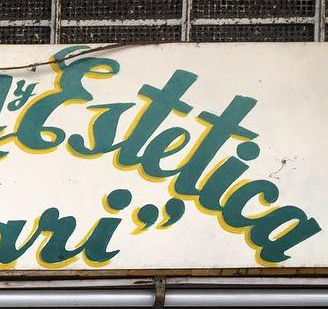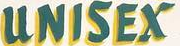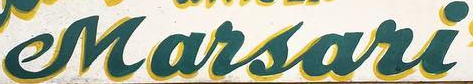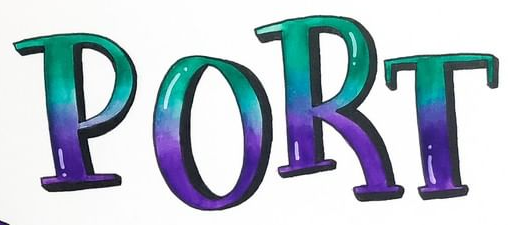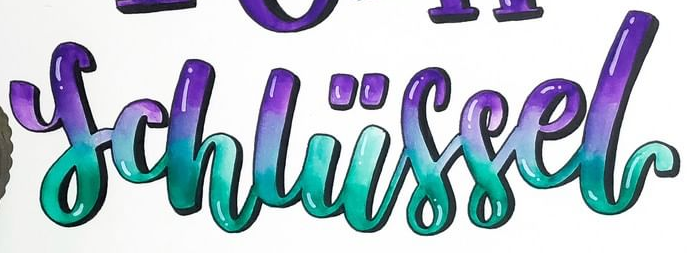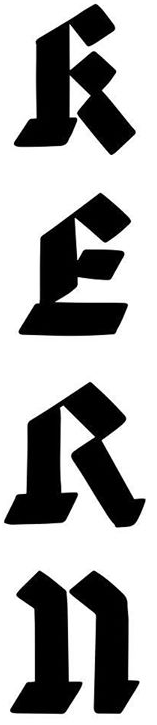What words are shown in these images in order, separated by a semicolon? Ertetica; UNISEX; Marsari; PORT; schliissel; RERn 